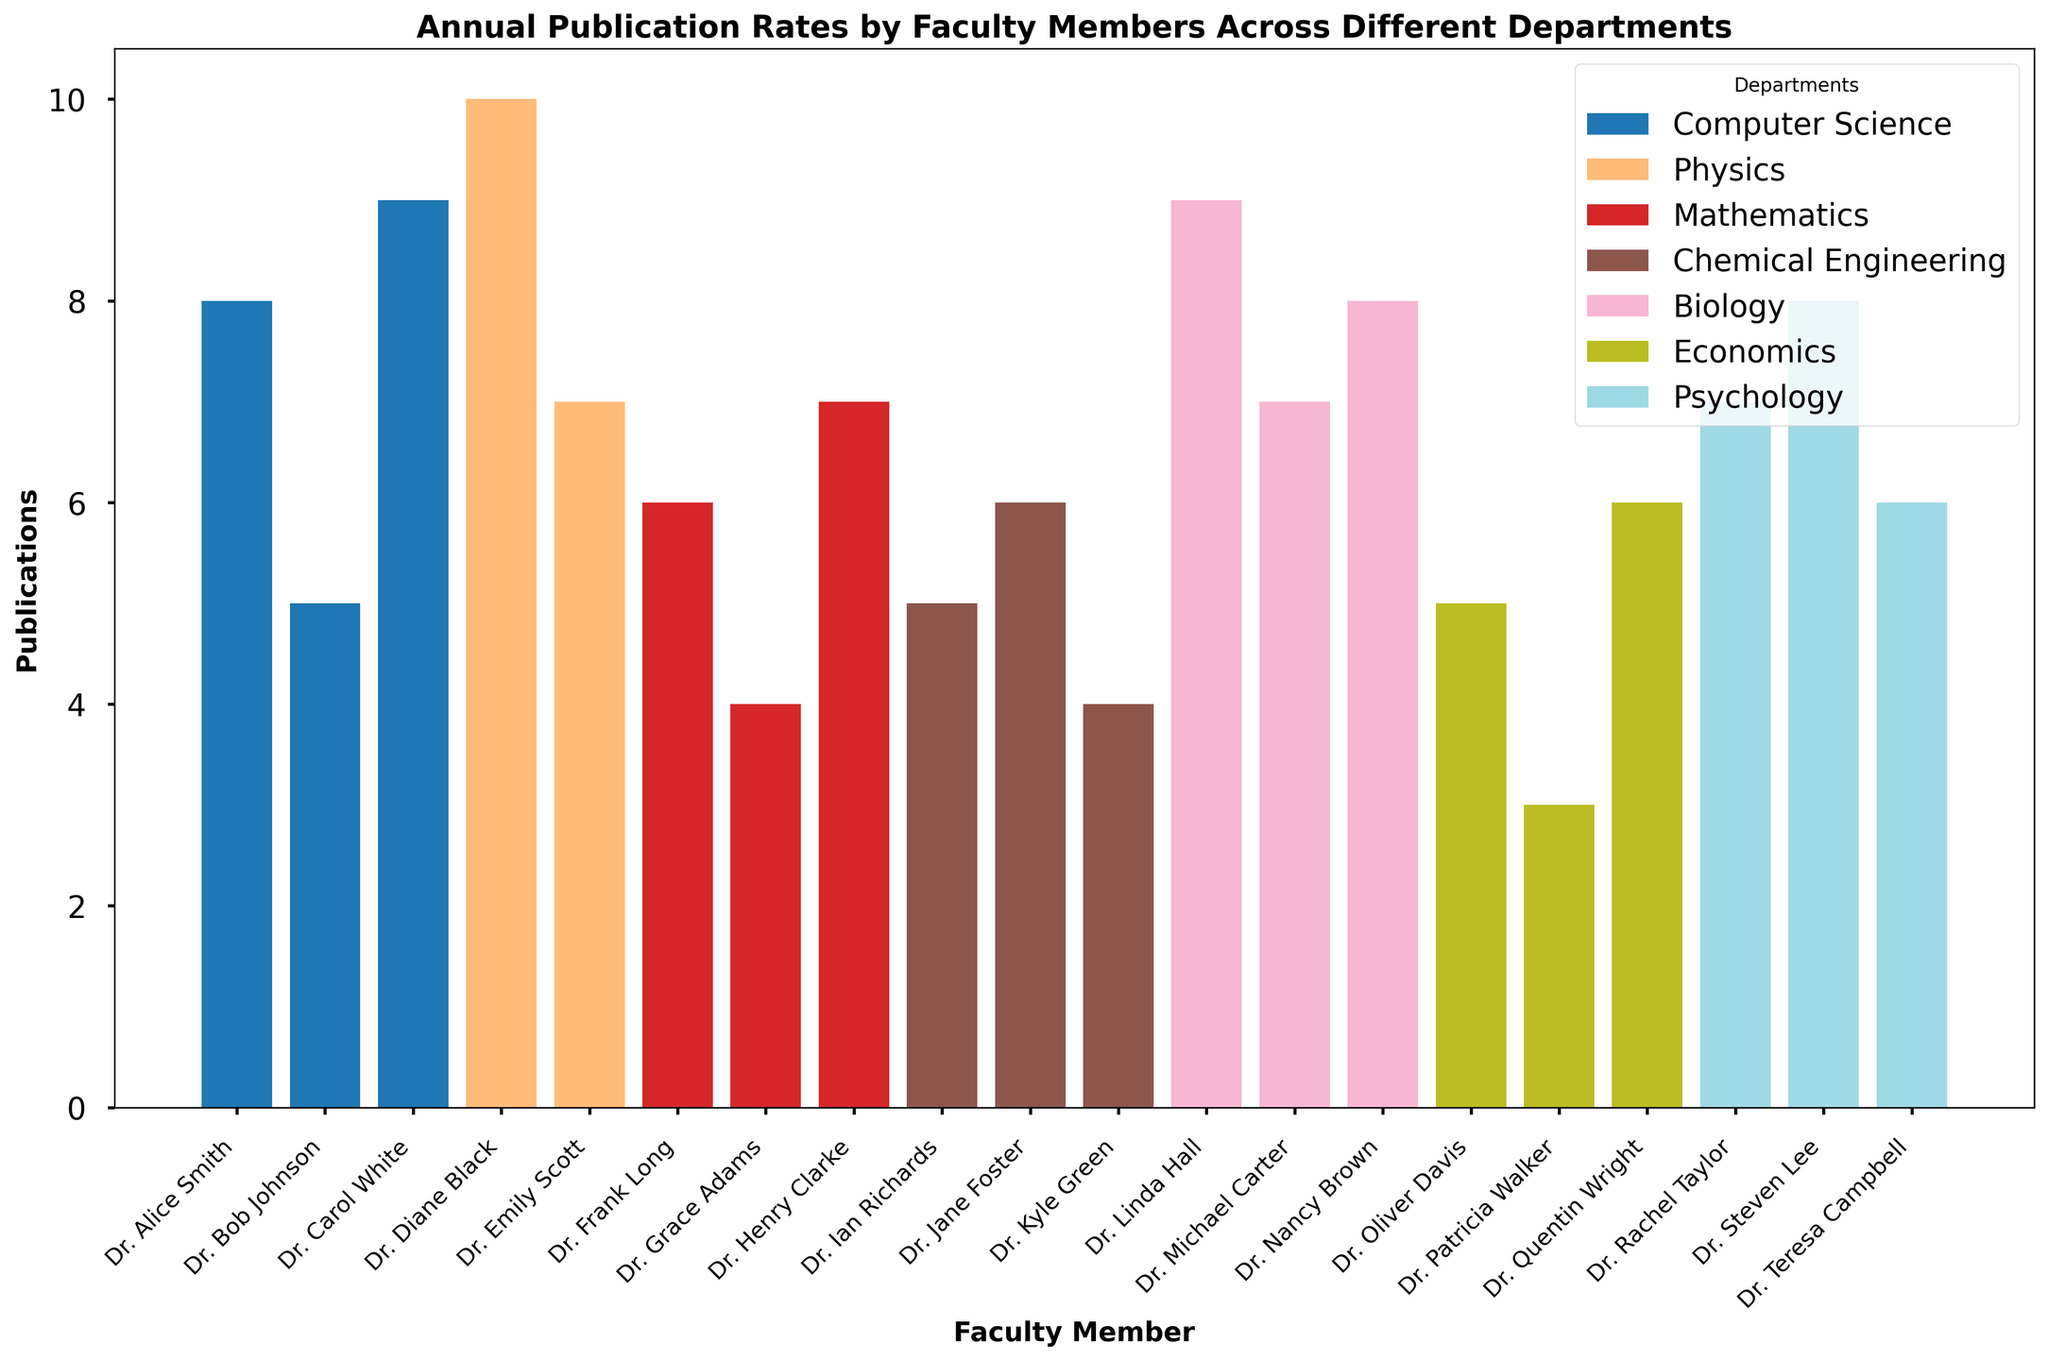Which department has the highest average number of publications per faculty member? Calculate the average number of publications for each department by summing the publications of the faculty members and dividing by the number of faculty members. Compare these averages to find the highest one. Computer Science: (8+5+9)/3 = 7.33, Physics: (10+7)/2 = 8.5, Mathematics: (6+4+7)/3 = 5.67, Chemical Engineering: (5+6+4)/3 = 5, Biology: (9+7+8)/3 = 8, Economics: (5+3+6)/3 = 4.67, Psychology: (7+8+6)/3 = 7
Answer: Physics Which faculty member has the highest number of publications? Identify the bar with the greatest height, which represents the faculty member with the highest publication count. Dr. Diane Black from Physics has 10 publications.
Answer: Dr. Diane Black What is the total number of publications for the Chemical Engineering department? Sum the number of publications of all faculty members in the Chemical Engineering department: 5 (Dr. Ian Richards) + 6 (Dr. Jane Foster) + 4 (Dr. Kyle Green) = 15
Answer: 15 Compare the number of publications between Dr. Alice Smith from Computer Science and Dr. Linda Hall from Biology. Who has more publications? Dr. Alice Smith has 8 publications and Dr. Linda Hall has 9 publications. Compare these two values to determine who has more.
Answer: Dr. Linda Hall What is the difference in the number of publications between the faculty member with the most publications and the one with the least in the Economics department? Identify the faculty members with the most and least publications in Economics. Dr. Quentin Wright has the most (6), and Dr. Patricia Walker has the least (3). Calculate the difference: 6 - 3 = 3
Answer: 3 